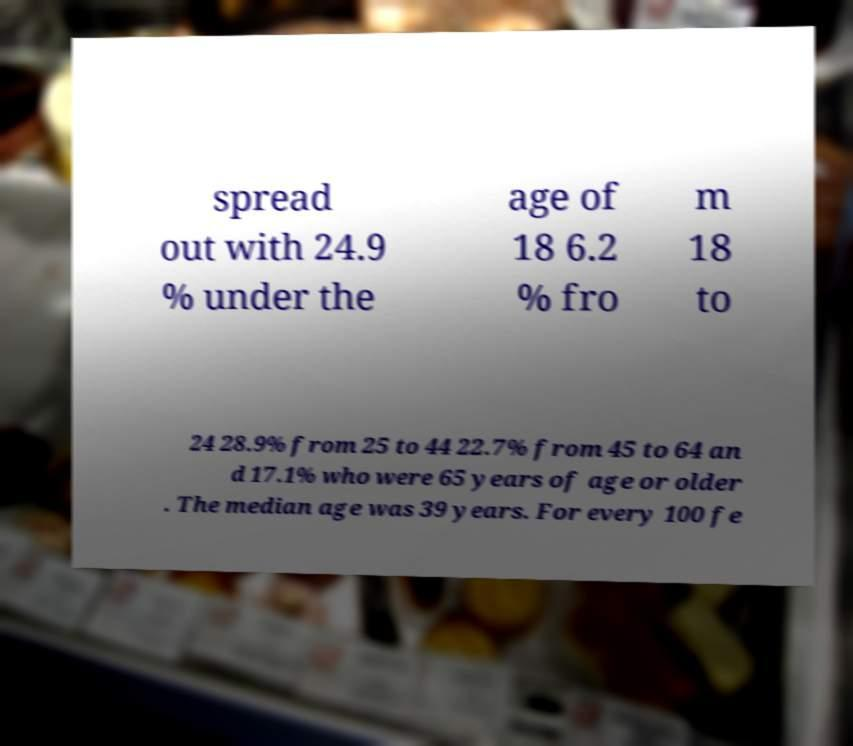There's text embedded in this image that I need extracted. Can you transcribe it verbatim? spread out with 24.9 % under the age of 18 6.2 % fro m 18 to 24 28.9% from 25 to 44 22.7% from 45 to 64 an d 17.1% who were 65 years of age or older . The median age was 39 years. For every 100 fe 